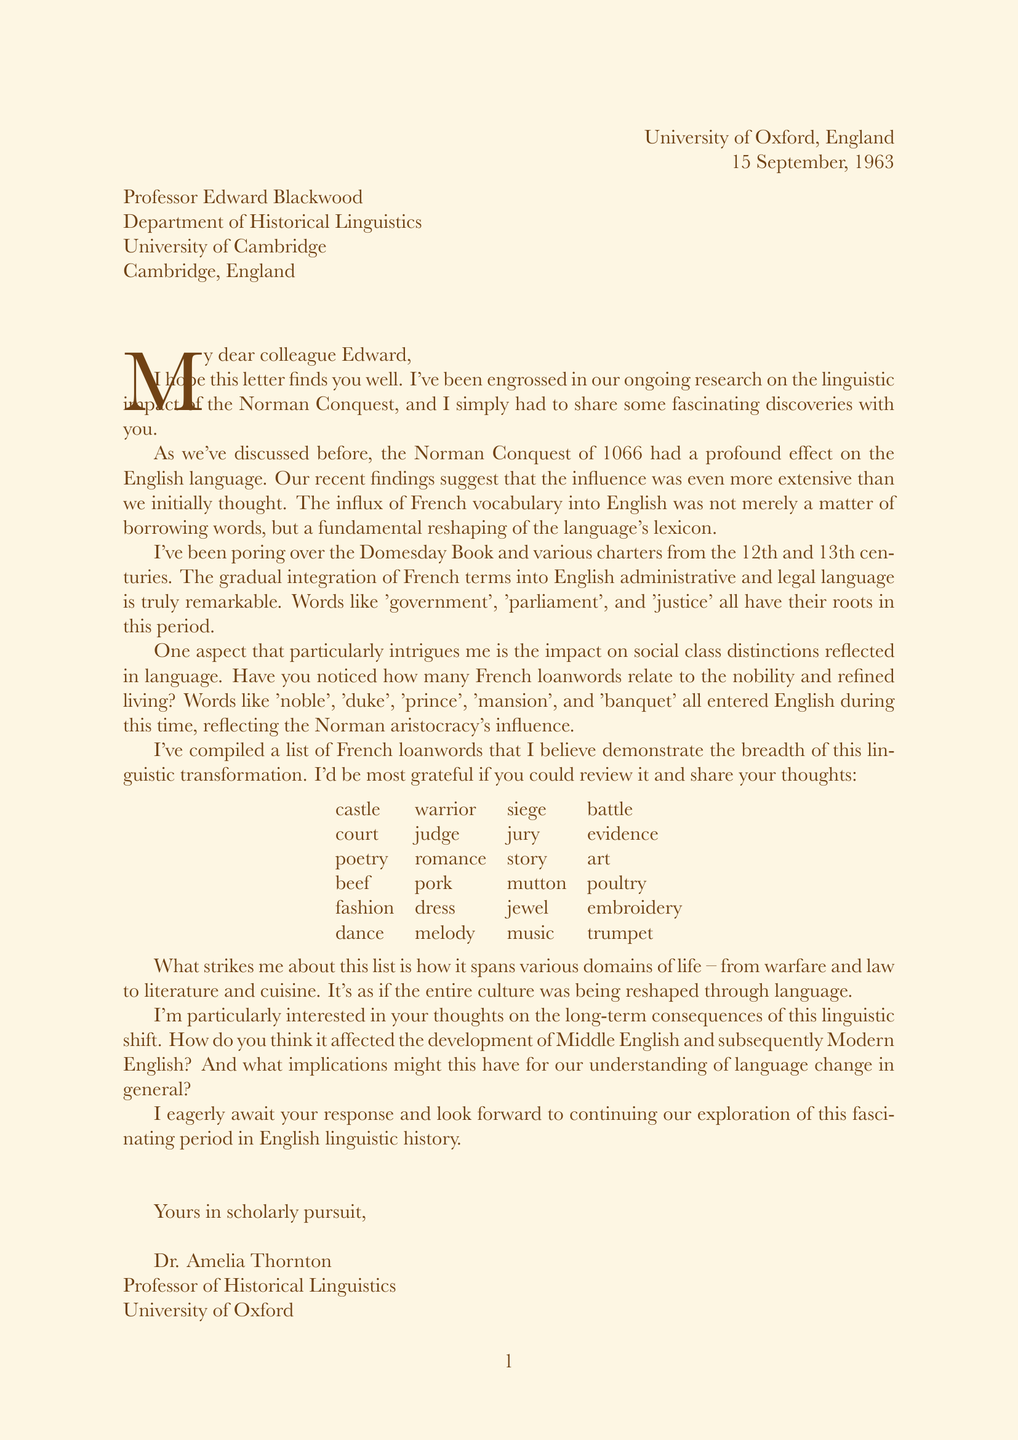What is the date of the letter? The date of the letter is mentioned at the beginning of the document.
Answer: 15 September, 1963 Who is the sender of the letter? The sender is identified in the letterhead.
Answer: Dr. Amelia Thornton What significant event does the letter discuss? The letter discusses the linguistic impact of a historical event.
Answer: Norman Conquest List one French loanword related to warfare mentioned in the letter. The letter provides a list of French loanwords and indicates their domains.
Answer: castle What aspect of language does the sender find particularly intriguing? The sender mentions a specific impact that is a recurring theme in the letter.
Answer: social class distinctions Which two periods are referenced in regards to the French influence on English language? The letter implies the influence occurred in specific historical contexts.
Answer: 12th and 13th centuries What does the sender request from the recipient regarding the list of loanwords? The sender seeks specific feedback on the included information in the list.
Answer: review it and share your thoughts What is the main purpose of this correspondence? The purpose of the letter is to share findings and seek thoughts on research.
Answer: discuss linguistic impact How does the sender feel about the topic? The sign-off and introduction provide insight into the sender's perspective.
Answer: eagerly await 